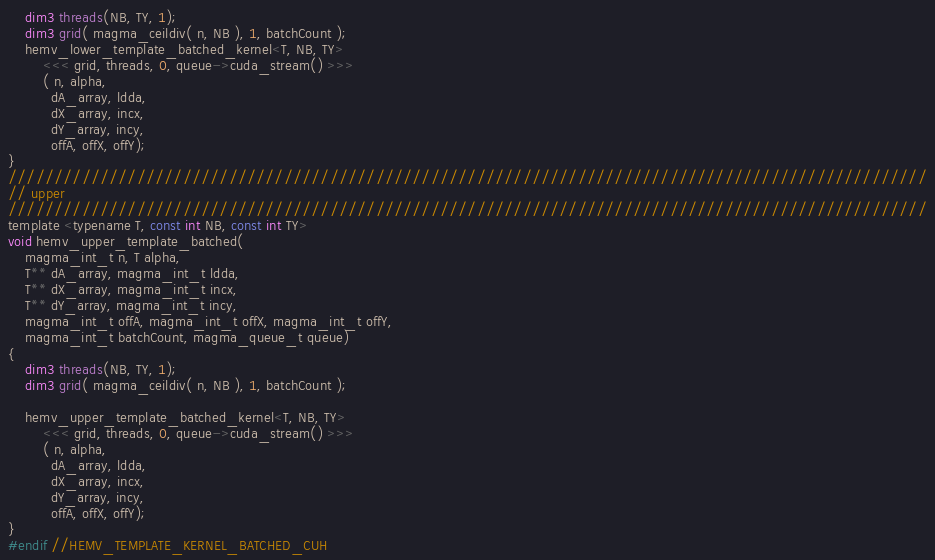Convert code to text. <code><loc_0><loc_0><loc_500><loc_500><_Cuda_>    dim3 threads(NB, TY, 1);
    dim3 grid( magma_ceildiv( n, NB ), 1, batchCount );
    hemv_lower_template_batched_kernel<T, NB, TY>
        <<< grid, threads, 0, queue->cuda_stream() >>>
        ( n, alpha, 
          dA_array, ldda, 
          dX_array, incx, 
          dY_array, incy, 
          offA, offX, offY);
}
////////////////////////////////////////////////////////////////////////////////////////////////////
// upper
////////////////////////////////////////////////////////////////////////////////////////////////////
template <typename T, const int NB, const int TY>
void hemv_upper_template_batched(
    magma_int_t n, T alpha, 
    T** dA_array, magma_int_t ldda,
    T** dX_array, magma_int_t incx,
    T** dY_array, magma_int_t incy,  
    magma_int_t offA, magma_int_t offX, magma_int_t offY, 
    magma_int_t batchCount, magma_queue_t queue)
{
    dim3 threads(NB, TY, 1);
    dim3 grid( magma_ceildiv( n, NB ), 1, batchCount );
    
    hemv_upper_template_batched_kernel<T, NB, TY>
        <<< grid, threads, 0, queue->cuda_stream() >>>
        ( n, alpha, 
          dA_array, ldda, 
          dX_array, incx, 
          dY_array, incy, 
          offA, offX, offY);
}
#endif //HEMV_TEMPLATE_KERNEL_BATCHED_CUH
</code> 